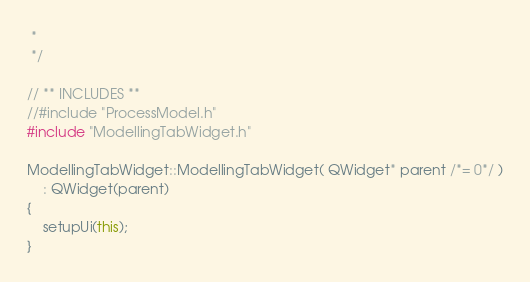Convert code to text. <code><loc_0><loc_0><loc_500><loc_500><_C++_> *
 */

// ** INCLUDES **
//#include "ProcessModel.h"
#include "ModellingTabWidget.h"

ModellingTabWidget::ModellingTabWidget( QWidget* parent /*= 0*/ )
    : QWidget(parent)
{
    setupUi(this);
}


</code> 